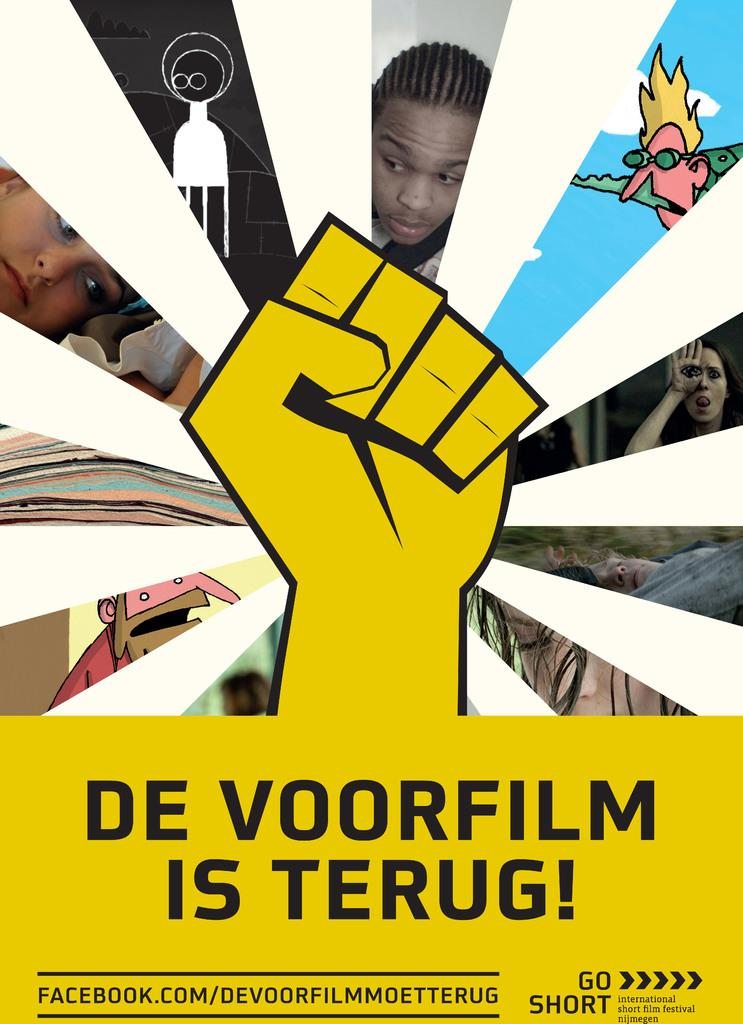What is the main object in the image? There is a poster in the image. What type of images are on the poster? The poster contains images of persons and cartoon images. Can you describe the hand shown on the poster? The poster shows a hand of a person. What else is present on the poster besides the images? There is text written on the poster. What type of boot is being exchanged in the image? There is no boot or exchange of any kind present in the image; it only features a poster with images and text. 